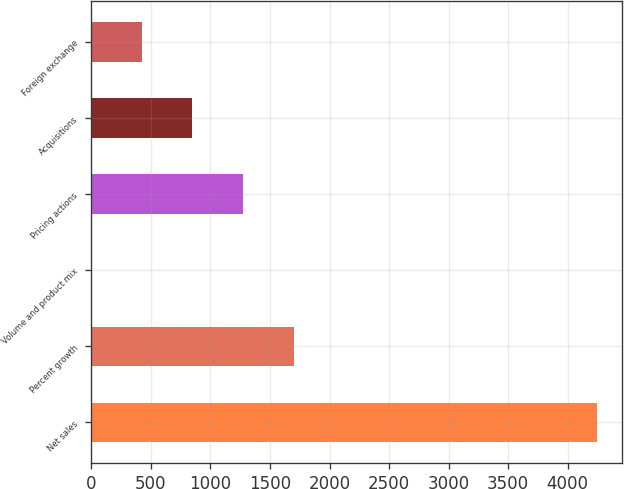Convert chart to OTSL. <chart><loc_0><loc_0><loc_500><loc_500><bar_chart><fcel>Net sales<fcel>Percent growth<fcel>Volume and product mix<fcel>Pricing actions<fcel>Acquisitions<fcel>Foreign exchange<nl><fcel>4243.2<fcel>1697.4<fcel>0.2<fcel>1273.1<fcel>848.8<fcel>424.5<nl></chart> 